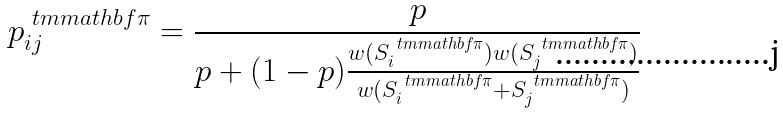<formula> <loc_0><loc_0><loc_500><loc_500>p _ { i j } ^ { \ t m m a t h b f { \pi } } = \frac { p } { p + ( 1 - p ) \frac { w ( S _ { i } ^ { \ t m m a t h b f { \pi } } ) w ( S _ { j } ^ { \ t m m a t h b f { \pi } } ) } { w ( S _ { i } ^ { \ t m m a t h b f { \pi } } + S _ { j } ^ { \ t m m a t h b f { \pi } } ) } }</formula> 